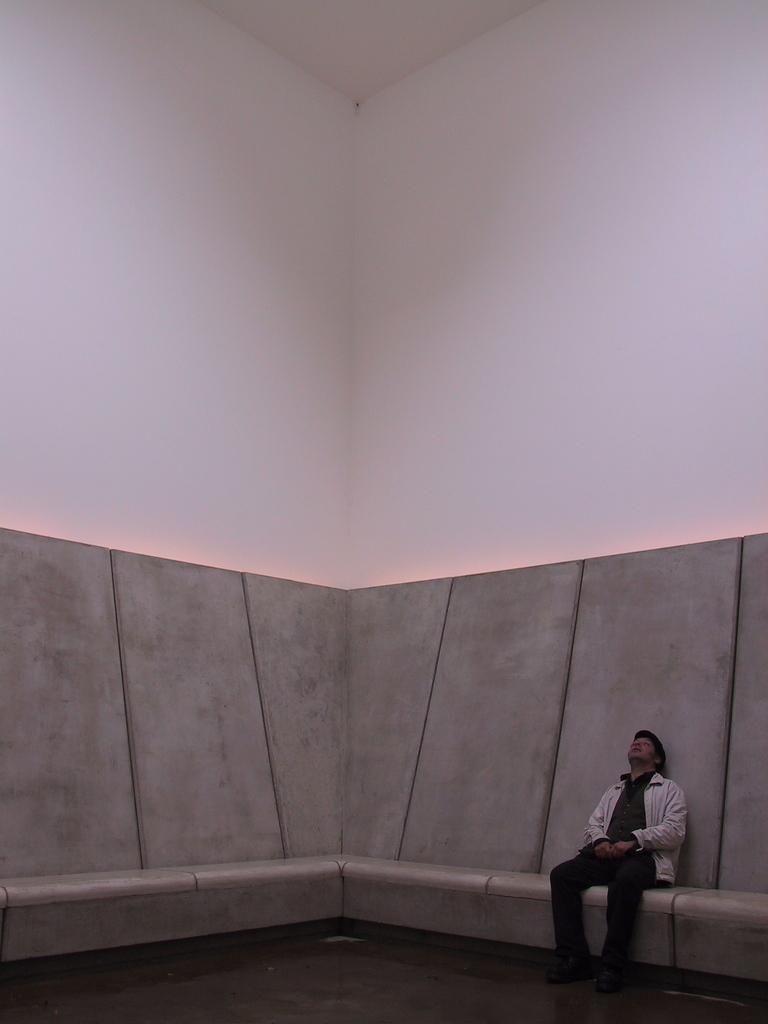How would you summarize this image in a sentence or two? In this image on the right side there is one person who is sitting and in the background there is a wall, at the bottom there is a floor. 